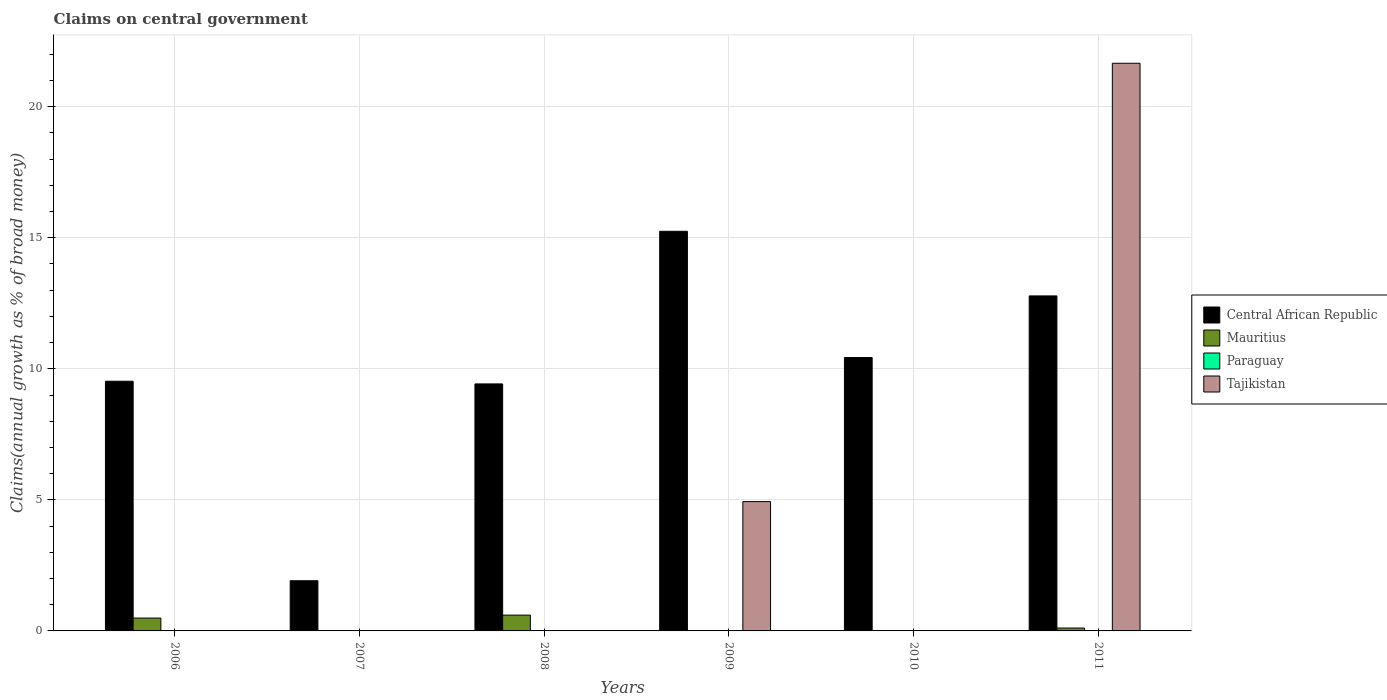How many different coloured bars are there?
Provide a short and direct response. 3. Are the number of bars on each tick of the X-axis equal?
Provide a short and direct response. No. How many bars are there on the 6th tick from the left?
Ensure brevity in your answer.  3. How many bars are there on the 3rd tick from the right?
Provide a succinct answer. 2. What is the label of the 1st group of bars from the left?
Your answer should be very brief. 2006. In how many cases, is the number of bars for a given year not equal to the number of legend labels?
Your answer should be compact. 6. What is the percentage of broad money claimed on centeral government in Tajikistan in 2011?
Ensure brevity in your answer.  21.66. Across all years, what is the maximum percentage of broad money claimed on centeral government in Central African Republic?
Ensure brevity in your answer.  15.25. Across all years, what is the minimum percentage of broad money claimed on centeral government in Mauritius?
Offer a terse response. 0. What is the total percentage of broad money claimed on centeral government in Tajikistan in the graph?
Keep it short and to the point. 26.59. What is the difference between the percentage of broad money claimed on centeral government in Tajikistan in 2009 and that in 2011?
Ensure brevity in your answer.  -16.72. What is the average percentage of broad money claimed on centeral government in Central African Republic per year?
Your response must be concise. 9.89. In the year 2008, what is the difference between the percentage of broad money claimed on centeral government in Central African Republic and percentage of broad money claimed on centeral government in Mauritius?
Your response must be concise. 8.82. In how many years, is the percentage of broad money claimed on centeral government in Central African Republic greater than 19 %?
Make the answer very short. 0. What is the ratio of the percentage of broad money claimed on centeral government in Central African Republic in 2007 to that in 2010?
Provide a succinct answer. 0.18. Is the percentage of broad money claimed on centeral government in Mauritius in 2006 less than that in 2011?
Ensure brevity in your answer.  No. Is the difference between the percentage of broad money claimed on centeral government in Central African Republic in 2006 and 2008 greater than the difference between the percentage of broad money claimed on centeral government in Mauritius in 2006 and 2008?
Your answer should be compact. Yes. What is the difference between the highest and the second highest percentage of broad money claimed on centeral government in Mauritius?
Offer a very short reply. 0.11. What is the difference between the highest and the lowest percentage of broad money claimed on centeral government in Tajikistan?
Your response must be concise. 21.66. In how many years, is the percentage of broad money claimed on centeral government in Mauritius greater than the average percentage of broad money claimed on centeral government in Mauritius taken over all years?
Make the answer very short. 2. Is it the case that in every year, the sum of the percentage of broad money claimed on centeral government in Paraguay and percentage of broad money claimed on centeral government in Mauritius is greater than the percentage of broad money claimed on centeral government in Central African Republic?
Provide a short and direct response. No. How many bars are there?
Offer a very short reply. 11. How many years are there in the graph?
Give a very brief answer. 6. Does the graph contain any zero values?
Offer a terse response. Yes. Does the graph contain grids?
Offer a very short reply. Yes. Where does the legend appear in the graph?
Offer a terse response. Center right. How many legend labels are there?
Make the answer very short. 4. How are the legend labels stacked?
Offer a terse response. Vertical. What is the title of the graph?
Ensure brevity in your answer.  Claims on central government. Does "Latin America(all income levels)" appear as one of the legend labels in the graph?
Offer a very short reply. No. What is the label or title of the Y-axis?
Keep it short and to the point. Claims(annual growth as % of broad money). What is the Claims(annual growth as % of broad money) of Central African Republic in 2006?
Keep it short and to the point. 9.53. What is the Claims(annual growth as % of broad money) of Mauritius in 2006?
Your response must be concise. 0.49. What is the Claims(annual growth as % of broad money) in Paraguay in 2006?
Your response must be concise. 0. What is the Claims(annual growth as % of broad money) of Central African Republic in 2007?
Keep it short and to the point. 1.91. What is the Claims(annual growth as % of broad money) in Tajikistan in 2007?
Offer a very short reply. 0. What is the Claims(annual growth as % of broad money) in Central African Republic in 2008?
Provide a short and direct response. 9.42. What is the Claims(annual growth as % of broad money) of Mauritius in 2008?
Your answer should be very brief. 0.6. What is the Claims(annual growth as % of broad money) in Tajikistan in 2008?
Provide a succinct answer. 0. What is the Claims(annual growth as % of broad money) of Central African Republic in 2009?
Keep it short and to the point. 15.25. What is the Claims(annual growth as % of broad money) of Mauritius in 2009?
Your answer should be very brief. 0. What is the Claims(annual growth as % of broad money) of Paraguay in 2009?
Ensure brevity in your answer.  0. What is the Claims(annual growth as % of broad money) in Tajikistan in 2009?
Ensure brevity in your answer.  4.93. What is the Claims(annual growth as % of broad money) in Central African Republic in 2010?
Your response must be concise. 10.43. What is the Claims(annual growth as % of broad money) in Central African Republic in 2011?
Offer a terse response. 12.78. What is the Claims(annual growth as % of broad money) in Mauritius in 2011?
Give a very brief answer. 0.11. What is the Claims(annual growth as % of broad money) in Tajikistan in 2011?
Offer a terse response. 21.66. Across all years, what is the maximum Claims(annual growth as % of broad money) in Central African Republic?
Make the answer very short. 15.25. Across all years, what is the maximum Claims(annual growth as % of broad money) in Mauritius?
Your answer should be very brief. 0.6. Across all years, what is the maximum Claims(annual growth as % of broad money) in Tajikistan?
Your answer should be compact. 21.66. Across all years, what is the minimum Claims(annual growth as % of broad money) in Central African Republic?
Your answer should be very brief. 1.91. Across all years, what is the minimum Claims(annual growth as % of broad money) of Tajikistan?
Your response must be concise. 0. What is the total Claims(annual growth as % of broad money) of Central African Republic in the graph?
Provide a succinct answer. 59.32. What is the total Claims(annual growth as % of broad money) of Mauritius in the graph?
Offer a terse response. 1.2. What is the total Claims(annual growth as % of broad money) in Tajikistan in the graph?
Your answer should be compact. 26.59. What is the difference between the Claims(annual growth as % of broad money) of Central African Republic in 2006 and that in 2007?
Give a very brief answer. 7.61. What is the difference between the Claims(annual growth as % of broad money) in Central African Republic in 2006 and that in 2008?
Ensure brevity in your answer.  0.1. What is the difference between the Claims(annual growth as % of broad money) in Mauritius in 2006 and that in 2008?
Ensure brevity in your answer.  -0.11. What is the difference between the Claims(annual growth as % of broad money) in Central African Republic in 2006 and that in 2009?
Offer a very short reply. -5.72. What is the difference between the Claims(annual growth as % of broad money) of Central African Republic in 2006 and that in 2010?
Offer a very short reply. -0.9. What is the difference between the Claims(annual growth as % of broad money) of Central African Republic in 2006 and that in 2011?
Ensure brevity in your answer.  -3.25. What is the difference between the Claims(annual growth as % of broad money) in Mauritius in 2006 and that in 2011?
Your response must be concise. 0.38. What is the difference between the Claims(annual growth as % of broad money) of Central African Republic in 2007 and that in 2008?
Offer a terse response. -7.51. What is the difference between the Claims(annual growth as % of broad money) in Central African Republic in 2007 and that in 2009?
Provide a succinct answer. -13.33. What is the difference between the Claims(annual growth as % of broad money) of Central African Republic in 2007 and that in 2010?
Keep it short and to the point. -8.52. What is the difference between the Claims(annual growth as % of broad money) in Central African Republic in 2007 and that in 2011?
Provide a short and direct response. -10.87. What is the difference between the Claims(annual growth as % of broad money) of Central African Republic in 2008 and that in 2009?
Your answer should be compact. -5.82. What is the difference between the Claims(annual growth as % of broad money) in Central African Republic in 2008 and that in 2010?
Provide a short and direct response. -1.01. What is the difference between the Claims(annual growth as % of broad money) of Central African Republic in 2008 and that in 2011?
Give a very brief answer. -3.36. What is the difference between the Claims(annual growth as % of broad money) in Mauritius in 2008 and that in 2011?
Ensure brevity in your answer.  0.49. What is the difference between the Claims(annual growth as % of broad money) in Central African Republic in 2009 and that in 2010?
Give a very brief answer. 4.82. What is the difference between the Claims(annual growth as % of broad money) of Central African Republic in 2009 and that in 2011?
Provide a short and direct response. 2.47. What is the difference between the Claims(annual growth as % of broad money) in Tajikistan in 2009 and that in 2011?
Ensure brevity in your answer.  -16.72. What is the difference between the Claims(annual growth as % of broad money) of Central African Republic in 2010 and that in 2011?
Provide a short and direct response. -2.35. What is the difference between the Claims(annual growth as % of broad money) of Central African Republic in 2006 and the Claims(annual growth as % of broad money) of Mauritius in 2008?
Ensure brevity in your answer.  8.92. What is the difference between the Claims(annual growth as % of broad money) in Central African Republic in 2006 and the Claims(annual growth as % of broad money) in Tajikistan in 2009?
Keep it short and to the point. 4.59. What is the difference between the Claims(annual growth as % of broad money) in Mauritius in 2006 and the Claims(annual growth as % of broad money) in Tajikistan in 2009?
Make the answer very short. -4.44. What is the difference between the Claims(annual growth as % of broad money) in Central African Republic in 2006 and the Claims(annual growth as % of broad money) in Mauritius in 2011?
Offer a terse response. 9.42. What is the difference between the Claims(annual growth as % of broad money) in Central African Republic in 2006 and the Claims(annual growth as % of broad money) in Tajikistan in 2011?
Offer a very short reply. -12.13. What is the difference between the Claims(annual growth as % of broad money) in Mauritius in 2006 and the Claims(annual growth as % of broad money) in Tajikistan in 2011?
Ensure brevity in your answer.  -21.17. What is the difference between the Claims(annual growth as % of broad money) in Central African Republic in 2007 and the Claims(annual growth as % of broad money) in Mauritius in 2008?
Provide a succinct answer. 1.31. What is the difference between the Claims(annual growth as % of broad money) in Central African Republic in 2007 and the Claims(annual growth as % of broad money) in Tajikistan in 2009?
Your answer should be very brief. -3.02. What is the difference between the Claims(annual growth as % of broad money) in Central African Republic in 2007 and the Claims(annual growth as % of broad money) in Mauritius in 2011?
Provide a short and direct response. 1.8. What is the difference between the Claims(annual growth as % of broad money) in Central African Republic in 2007 and the Claims(annual growth as % of broad money) in Tajikistan in 2011?
Keep it short and to the point. -19.74. What is the difference between the Claims(annual growth as % of broad money) of Central African Republic in 2008 and the Claims(annual growth as % of broad money) of Tajikistan in 2009?
Keep it short and to the point. 4.49. What is the difference between the Claims(annual growth as % of broad money) of Mauritius in 2008 and the Claims(annual growth as % of broad money) of Tajikistan in 2009?
Provide a short and direct response. -4.33. What is the difference between the Claims(annual growth as % of broad money) in Central African Republic in 2008 and the Claims(annual growth as % of broad money) in Mauritius in 2011?
Your answer should be compact. 9.31. What is the difference between the Claims(annual growth as % of broad money) in Central African Republic in 2008 and the Claims(annual growth as % of broad money) in Tajikistan in 2011?
Keep it short and to the point. -12.23. What is the difference between the Claims(annual growth as % of broad money) in Mauritius in 2008 and the Claims(annual growth as % of broad money) in Tajikistan in 2011?
Provide a succinct answer. -21.06. What is the difference between the Claims(annual growth as % of broad money) in Central African Republic in 2009 and the Claims(annual growth as % of broad money) in Mauritius in 2011?
Provide a short and direct response. 15.14. What is the difference between the Claims(annual growth as % of broad money) in Central African Republic in 2009 and the Claims(annual growth as % of broad money) in Tajikistan in 2011?
Ensure brevity in your answer.  -6.41. What is the difference between the Claims(annual growth as % of broad money) of Central African Republic in 2010 and the Claims(annual growth as % of broad money) of Mauritius in 2011?
Your answer should be compact. 10.32. What is the difference between the Claims(annual growth as % of broad money) of Central African Republic in 2010 and the Claims(annual growth as % of broad money) of Tajikistan in 2011?
Provide a succinct answer. -11.23. What is the average Claims(annual growth as % of broad money) of Central African Republic per year?
Provide a succinct answer. 9.89. What is the average Claims(annual growth as % of broad money) in Mauritius per year?
Provide a succinct answer. 0.2. What is the average Claims(annual growth as % of broad money) of Paraguay per year?
Your response must be concise. 0. What is the average Claims(annual growth as % of broad money) of Tajikistan per year?
Offer a very short reply. 4.43. In the year 2006, what is the difference between the Claims(annual growth as % of broad money) of Central African Republic and Claims(annual growth as % of broad money) of Mauritius?
Ensure brevity in your answer.  9.04. In the year 2008, what is the difference between the Claims(annual growth as % of broad money) in Central African Republic and Claims(annual growth as % of broad money) in Mauritius?
Keep it short and to the point. 8.82. In the year 2009, what is the difference between the Claims(annual growth as % of broad money) in Central African Republic and Claims(annual growth as % of broad money) in Tajikistan?
Give a very brief answer. 10.31. In the year 2011, what is the difference between the Claims(annual growth as % of broad money) in Central African Republic and Claims(annual growth as % of broad money) in Mauritius?
Provide a succinct answer. 12.67. In the year 2011, what is the difference between the Claims(annual growth as % of broad money) of Central African Republic and Claims(annual growth as % of broad money) of Tajikistan?
Offer a terse response. -8.88. In the year 2011, what is the difference between the Claims(annual growth as % of broad money) of Mauritius and Claims(annual growth as % of broad money) of Tajikistan?
Provide a succinct answer. -21.55. What is the ratio of the Claims(annual growth as % of broad money) in Central African Republic in 2006 to that in 2007?
Your answer should be very brief. 4.98. What is the ratio of the Claims(annual growth as % of broad money) of Central African Republic in 2006 to that in 2008?
Provide a succinct answer. 1.01. What is the ratio of the Claims(annual growth as % of broad money) of Mauritius in 2006 to that in 2008?
Ensure brevity in your answer.  0.81. What is the ratio of the Claims(annual growth as % of broad money) of Central African Republic in 2006 to that in 2009?
Ensure brevity in your answer.  0.62. What is the ratio of the Claims(annual growth as % of broad money) of Central African Republic in 2006 to that in 2010?
Keep it short and to the point. 0.91. What is the ratio of the Claims(annual growth as % of broad money) of Central African Republic in 2006 to that in 2011?
Keep it short and to the point. 0.75. What is the ratio of the Claims(annual growth as % of broad money) in Mauritius in 2006 to that in 2011?
Keep it short and to the point. 4.46. What is the ratio of the Claims(annual growth as % of broad money) of Central African Republic in 2007 to that in 2008?
Your answer should be very brief. 0.2. What is the ratio of the Claims(annual growth as % of broad money) in Central African Republic in 2007 to that in 2009?
Provide a succinct answer. 0.13. What is the ratio of the Claims(annual growth as % of broad money) of Central African Republic in 2007 to that in 2010?
Provide a succinct answer. 0.18. What is the ratio of the Claims(annual growth as % of broad money) in Central African Republic in 2007 to that in 2011?
Make the answer very short. 0.15. What is the ratio of the Claims(annual growth as % of broad money) in Central African Republic in 2008 to that in 2009?
Provide a short and direct response. 0.62. What is the ratio of the Claims(annual growth as % of broad money) of Central African Republic in 2008 to that in 2010?
Your answer should be very brief. 0.9. What is the ratio of the Claims(annual growth as % of broad money) of Central African Republic in 2008 to that in 2011?
Your response must be concise. 0.74. What is the ratio of the Claims(annual growth as % of broad money) of Mauritius in 2008 to that in 2011?
Ensure brevity in your answer.  5.48. What is the ratio of the Claims(annual growth as % of broad money) in Central African Republic in 2009 to that in 2010?
Ensure brevity in your answer.  1.46. What is the ratio of the Claims(annual growth as % of broad money) in Central African Republic in 2009 to that in 2011?
Keep it short and to the point. 1.19. What is the ratio of the Claims(annual growth as % of broad money) in Tajikistan in 2009 to that in 2011?
Ensure brevity in your answer.  0.23. What is the ratio of the Claims(annual growth as % of broad money) of Central African Republic in 2010 to that in 2011?
Keep it short and to the point. 0.82. What is the difference between the highest and the second highest Claims(annual growth as % of broad money) of Central African Republic?
Provide a short and direct response. 2.47. What is the difference between the highest and the second highest Claims(annual growth as % of broad money) of Mauritius?
Provide a succinct answer. 0.11. What is the difference between the highest and the lowest Claims(annual growth as % of broad money) in Central African Republic?
Ensure brevity in your answer.  13.33. What is the difference between the highest and the lowest Claims(annual growth as % of broad money) of Mauritius?
Keep it short and to the point. 0.6. What is the difference between the highest and the lowest Claims(annual growth as % of broad money) of Tajikistan?
Provide a succinct answer. 21.66. 